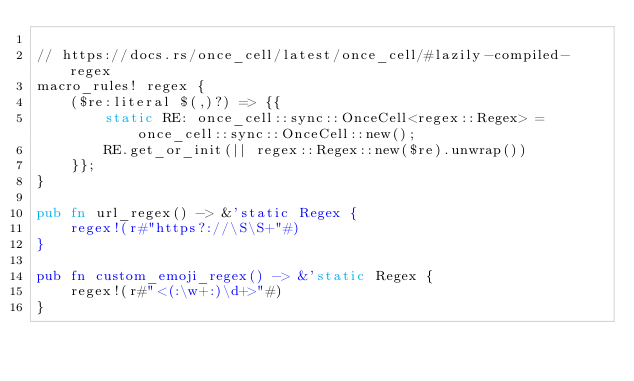Convert code to text. <code><loc_0><loc_0><loc_500><loc_500><_Rust_>
// https://docs.rs/once_cell/latest/once_cell/#lazily-compiled-regex
macro_rules! regex {
    ($re:literal $(,)?) => {{
        static RE: once_cell::sync::OnceCell<regex::Regex> = once_cell::sync::OnceCell::new();
        RE.get_or_init(|| regex::Regex::new($re).unwrap())
    }};
}

pub fn url_regex() -> &'static Regex {
    regex!(r#"https?://\S\S+"#)
}

pub fn custom_emoji_regex() -> &'static Regex {
    regex!(r#"<(:\w+:)\d+>"#)
}
</code> 